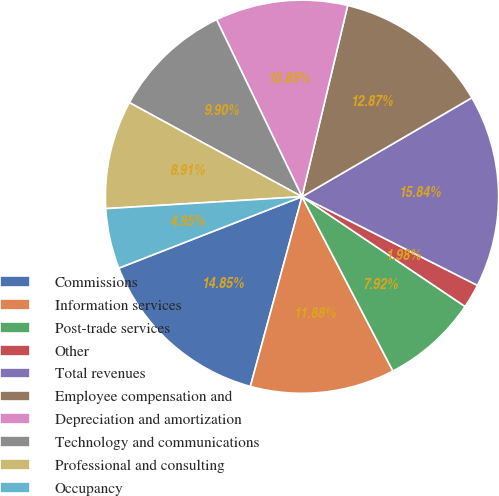<chart> <loc_0><loc_0><loc_500><loc_500><pie_chart><fcel>Commissions<fcel>Information services<fcel>Post-trade services<fcel>Other<fcel>Total revenues<fcel>Employee compensation and<fcel>Depreciation and amortization<fcel>Technology and communications<fcel>Professional and consulting<fcel>Occupancy<nl><fcel>14.85%<fcel>11.88%<fcel>7.92%<fcel>1.98%<fcel>15.84%<fcel>12.87%<fcel>10.89%<fcel>9.9%<fcel>8.91%<fcel>4.95%<nl></chart> 